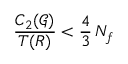Convert formula to latex. <formula><loc_0><loc_0><loc_500><loc_500>\frac { C _ { 2 } ( \mathcal { G } ) } { T ( R ) } < \frac { 4 } { 3 } \, N _ { f }</formula> 